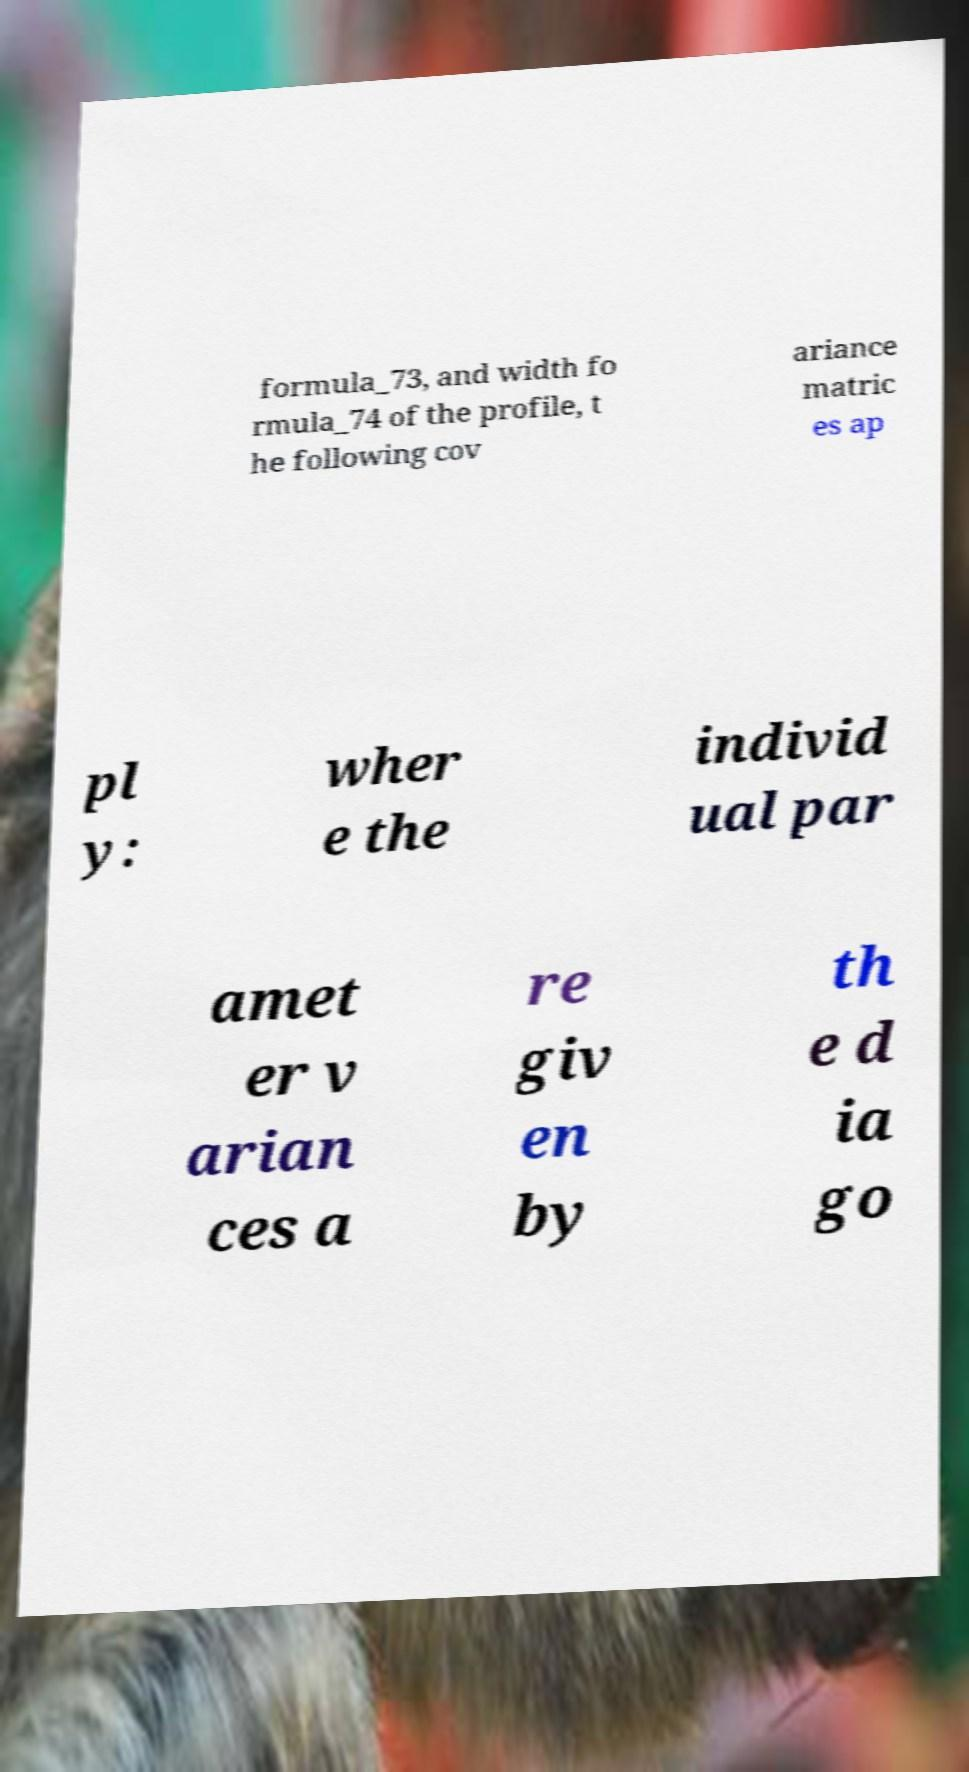Can you read and provide the text displayed in the image?This photo seems to have some interesting text. Can you extract and type it out for me? formula_73, and width fo rmula_74 of the profile, t he following cov ariance matric es ap pl y: wher e the individ ual par amet er v arian ces a re giv en by th e d ia go 